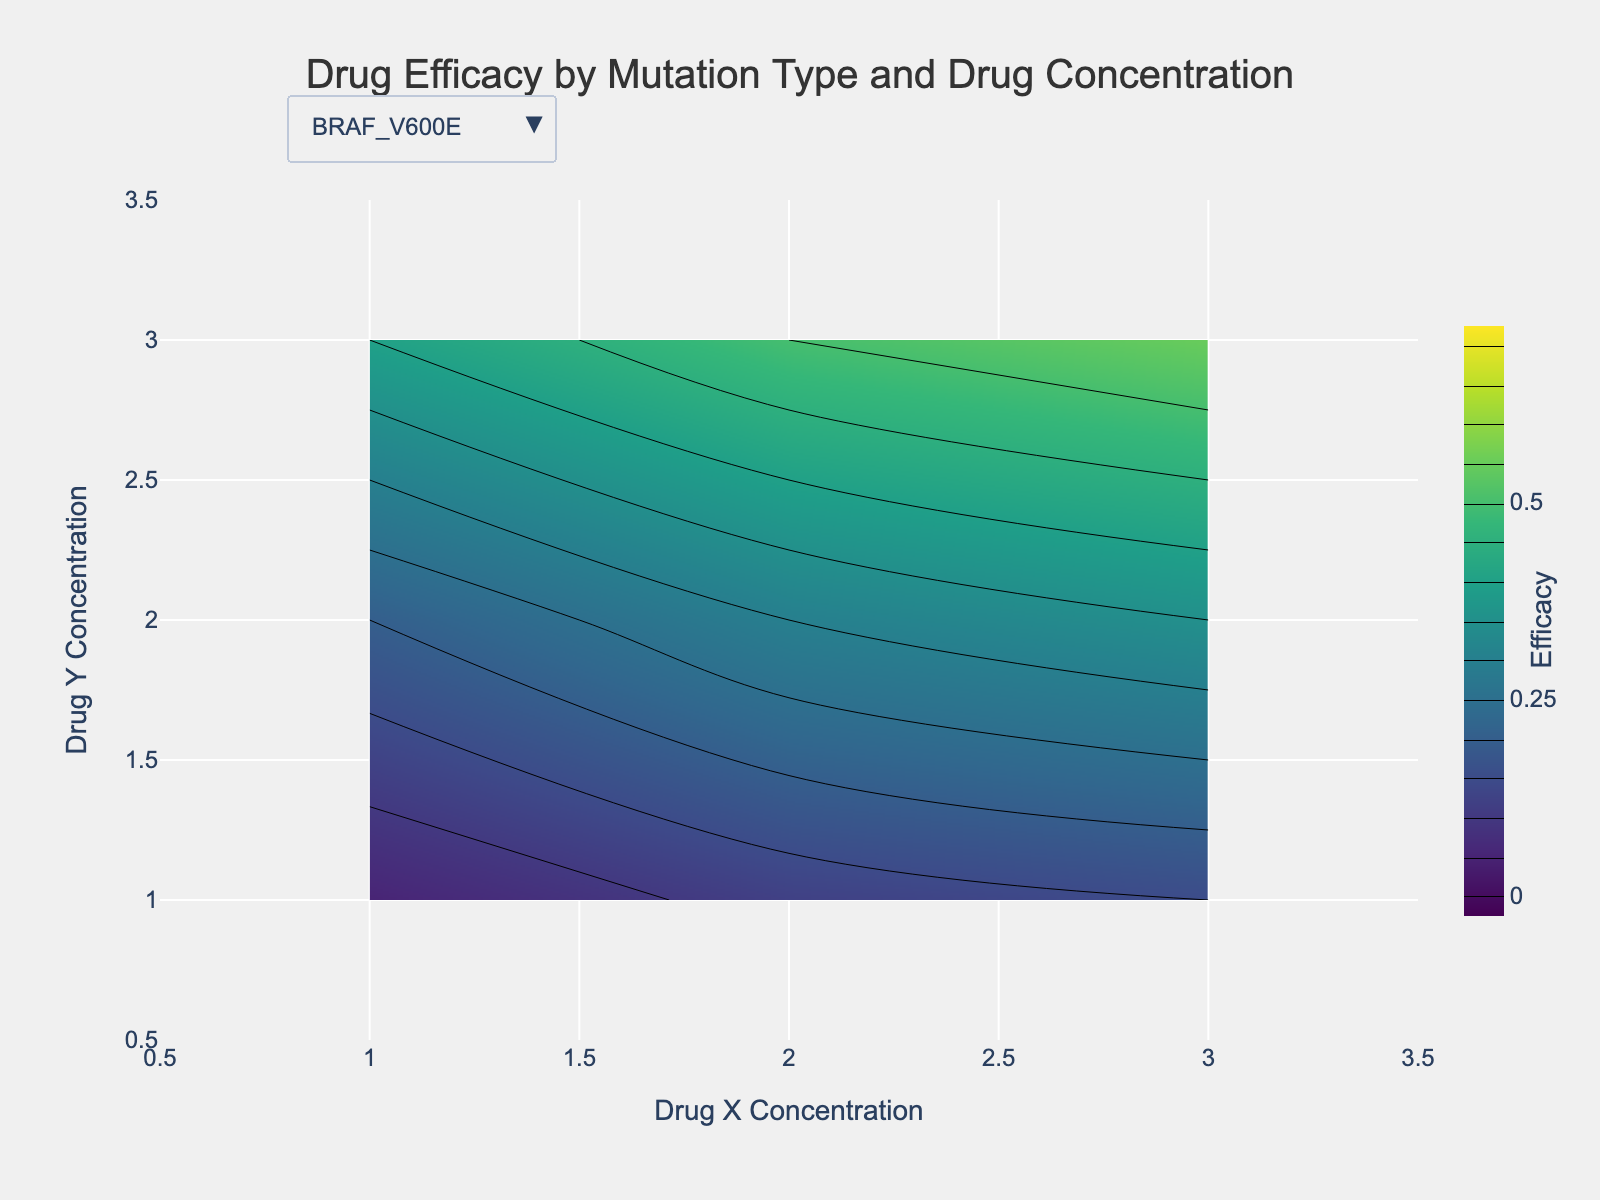What is the title of the plot? The title of the plot is located at the top of the figure. It is written in a larger font size compared to the other text elements and centered horizontally. The title gives an overview of what the figure represents.
Answer: Drug Efficacy by Mutation Type and Drug Concentration What are the x and y-axis titles in the plot? The titles of the x and y-axes are written near the respective axes. The x-axis title is below the horizontal axis, and the y-axis title is to the left of the vertical axis. These titles usually describe what each axis represents in the plot.
Answer: Drug X Concentration and Drug Y Concentration How does the efficacy of the drug change with increasing concentrations of Drug X and Drug Y for the PIK3CA_H1047R mutation? By examining the contour plot for the PIK3CA_H1047R mutation, one can observe that efficacy increases as both Drug X and Drug Y concentrations increase. This can be confirmed by the contour lines and color gradient, where higher values of efficacy are indicated by more intense colors.
Answer: Efficacy increases Which mutation type shows the highest efficacy at maximum concentrations of both drugs? To determine this, you should look at the efficacy values at the highest concentration points (3,3) for each mutation type. The mutation type with the highest efficacy value at these coordinates is the one with the highest drug response.
Answer: PIK3CA_H1047R For the BRAF_V600E mutation, how does the efficacy change when increasing the Drug X concentration from 1 to 3 while keeping Drug Y concentration constant at 2? For the BRAF_V600E mutation, observe the efficacy values at Drug Y concentration 2 and Drug X concentrations of 1, 2, and 3. Compare these values to understand how the efficacy changes.
Answer: Increases from 0.12 to 0.50 How does the efficacy for the KRAS_G12D mutation at Drug X concentration of 2 and Drug Y concentration of 2 compare to the efficacy for the EGFR_L858R mutation under the same conditions? Locate the efficacy values for both mutations at the specified concentrations. The efficacy for KRAS_G12D is 0.32, whereas for EGFR_L858R it is 0.35. Compare these values directly.
Answer: EGFR_L858R has higher efficacy Considering the BRAF_V600E and KRAS_G12D mutations, which drug combination (Drug X and Drug Y concentrations) leads to the highest efficacy, and what is that efficacy value? For each mutation type, find the maximum efficacy value in their respective contour plots and note the corresponding drug concentration combination. For BRAF_V600E, the maximum efficacy is found at (3,3) with 0.55. For KRAS_G12D, it is also at (3,3) with 0.58. Compare these values.
Answer: KRAS_G12D at (3,3) with 0.58 What is the color scale used in the contour plots and what does it represent? The color scale lies alongside the contour plot. Different colors indicate different efficacy levels, generally with the scale title "Efficacy." The color intensity reflects changing efficacy values from low to high.
Answer: Viridis representing efficacy How does the efficacy of the drug change when moving from (1,1) to (2,2) for the EGFR_L858R mutation? Locate the efficacy values at (1,1) and (2,2) for the EGFR_L858R mutation in the contour plot. The efficacy at (1,1) is 0.10, and at (2,2), it is 0.35. Compare these values to see the change.
Answer: Increases from 0.10 to 0.35 What general trend can be observed from the contour plots regarding drug efficacy across all mutation types for increasing drug concentrations? By observing all contour plots, a general trend is noted where the efficacy tends to increase with increasing concentrations of both Drug X and Drug Y. This trend is highlighted by the contour lines and color gradients in the plots.
Answer: Efficacy increases with increasing drug concentrations 